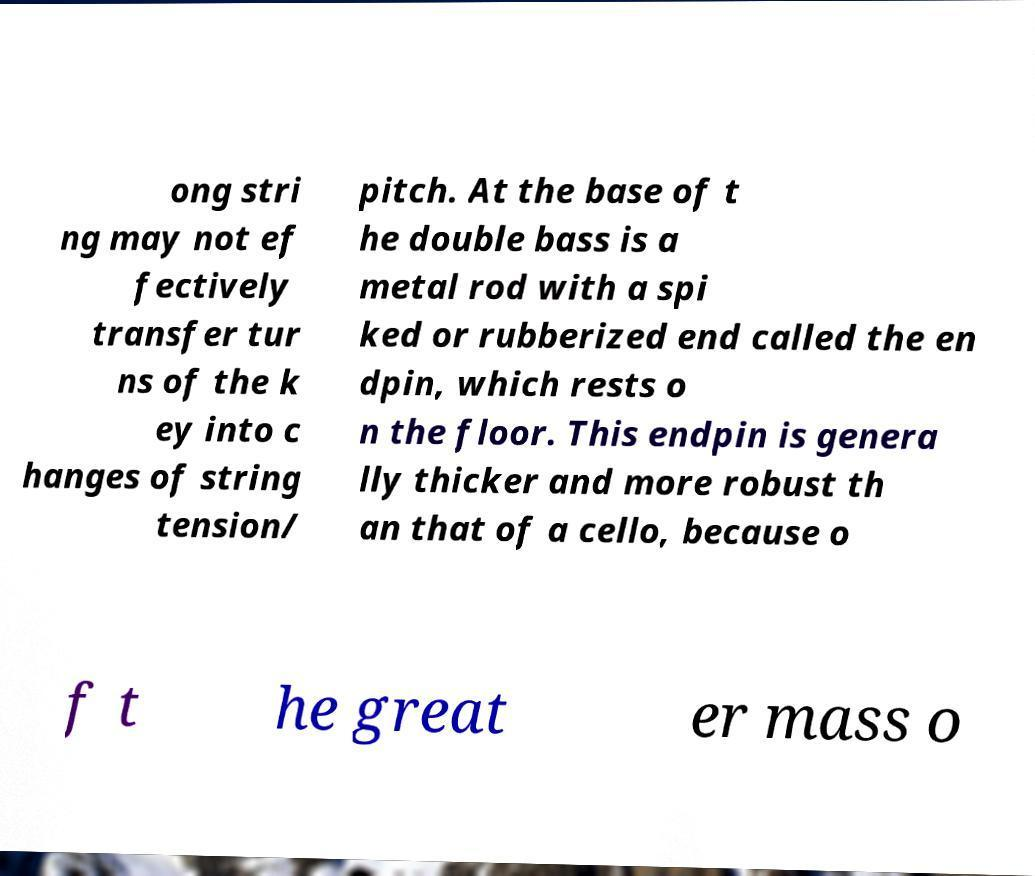Please identify and transcribe the text found in this image. ong stri ng may not ef fectively transfer tur ns of the k ey into c hanges of string tension/ pitch. At the base of t he double bass is a metal rod with a spi ked or rubberized end called the en dpin, which rests o n the floor. This endpin is genera lly thicker and more robust th an that of a cello, because o f t he great er mass o 